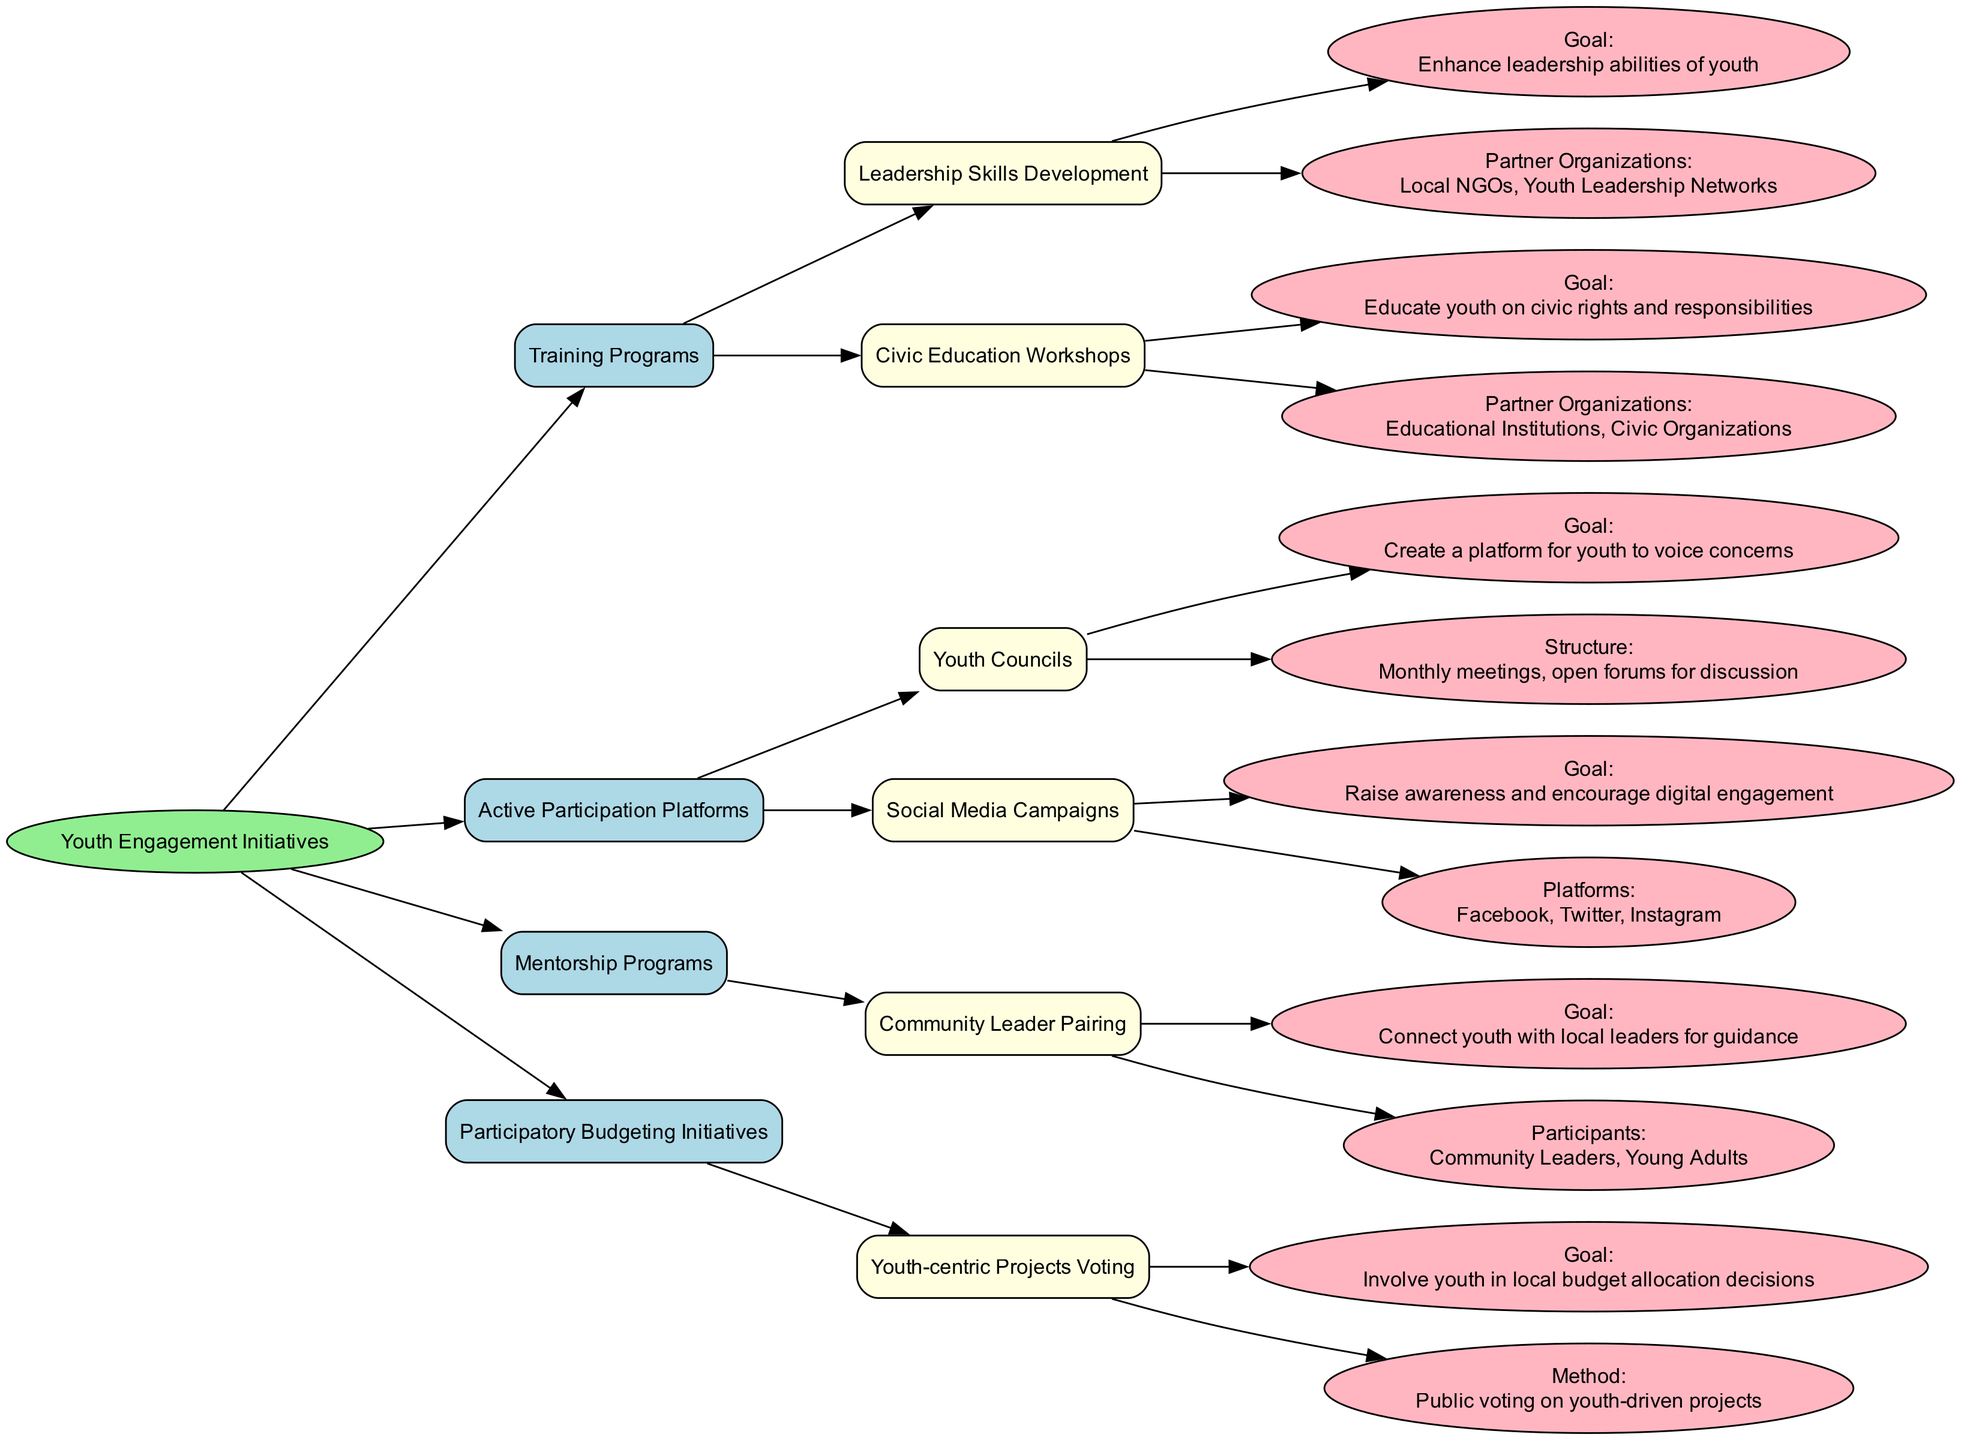What are the main types of initiatives listed in the decision tree? The decision tree categorizes youth engagement initiatives into four main types: Training Programs, Active Participation Platforms, Mentorship Programs, and Participatory Budgeting Initiatives. These can be identified as the major branches stemming from the root node.
Answer: Training Programs, Active Participation Platforms, Mentorship Programs, Participatory Budgeting Initiatives How many partner organizations are involved in Civic Education Workshops? The Civic Education Workshops initiative lists two partner organizations: Educational Institutions and Civic Organizations. By counting these listed partners, we find that there are two organizations involved.
Answer: 2 What is the goal of the Youth Councils? The Youth Councils initiative has a clear goal stated in the diagram: to create a platform for youth to voice concerns. This direct goal can be extracted from the corresponding node detailing the Youth Councils.
Answer: Create a platform for youth to voice concerns Which platforms are used in the Social Media Campaigns? The Social Media Campaigns initiative specifies three platforms for engagement: Facebook, Twitter, and Instagram. These platforms can be found listed under the information for Social Media Campaigns.
Answer: Facebook, Twitter, Instagram What method is used in Youth-centric Projects Voting? The method for the Youth-centric Projects Voting initiative is documented as public voting on youth-driven projects. This method can be directly referenced from the corresponding node in the decision tree.
Answer: Public voting on youth-driven projects Which initiative focuses on connecting youth with local leaders? The initiative that focuses on connecting youth with local leaders is the Community Leader Pairing under Mentorship Programs. This connection is explicitly stated in the respective goals within that initiative.
Answer: Community Leader Pairing How many training programs are listed in the diagram? There are two training programs listed under the Training Programs category: Leadership Skills Development and Civic Education Workshops. By counting these names, it’s determined that there are two training programs.
Answer: 2 What is the structure of Youth Councils? The structure of Youth Councils is described as monthly meetings and open forums for discussion. This structural detail can be extracted from the node associated with Youth Councils.
Answer: Monthly meetings, open forums for discussion What is the overall goal of the initiatives outlined in the diagram? While individual initiatives have specific goals, the overall aim can be inferred as promoting youth engagement in local governance. This overarching goal is suggested by the title of the diagram and the interconnected nature of the initiatives.
Answer: Promote youth engagement in local governance 